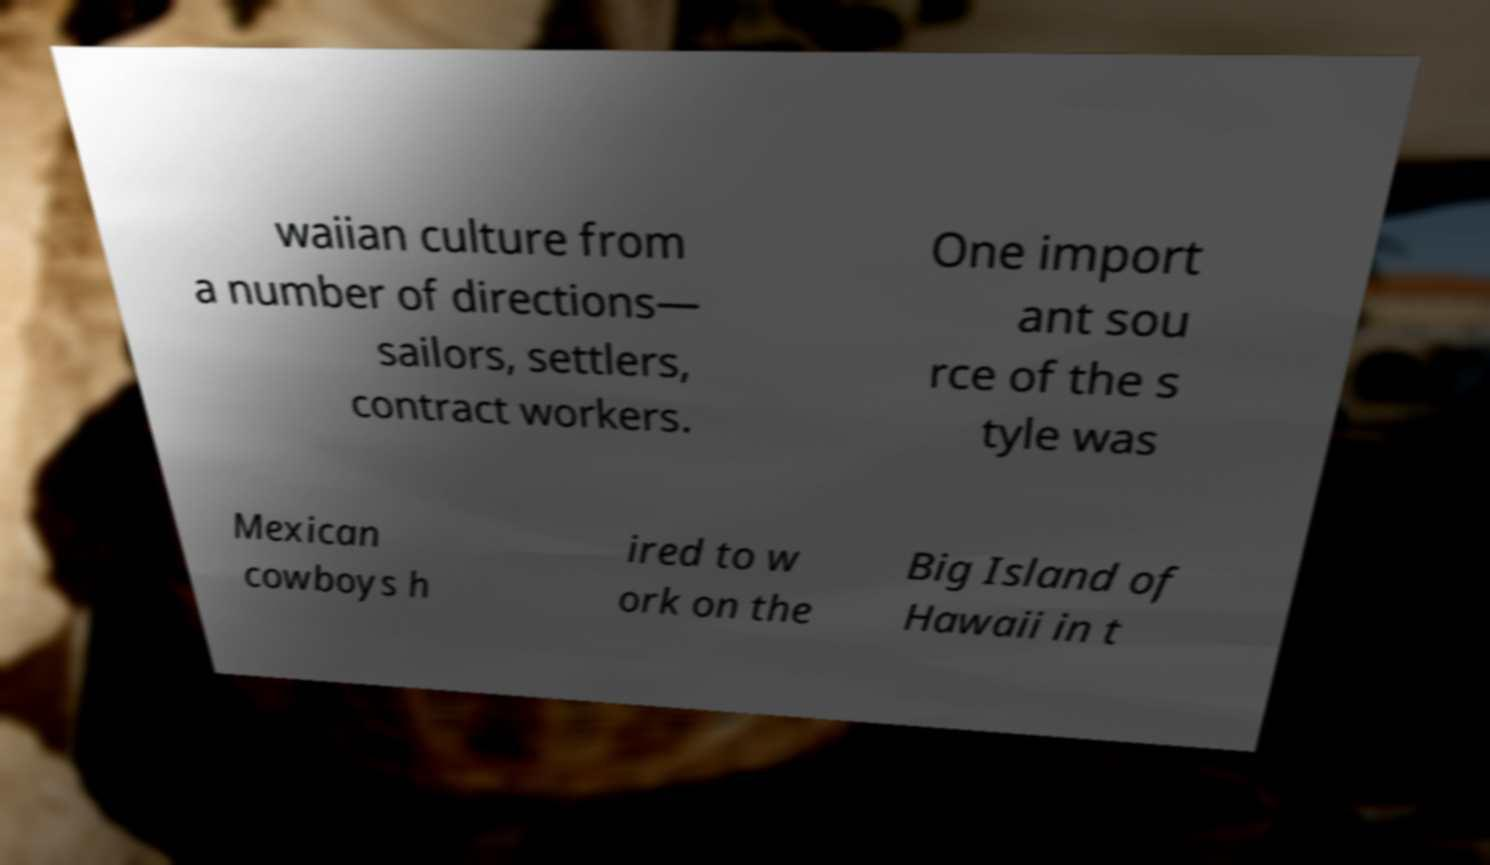Could you assist in decoding the text presented in this image and type it out clearly? waiian culture from a number of directions— sailors, settlers, contract workers. One import ant sou rce of the s tyle was Mexican cowboys h ired to w ork on the Big Island of Hawaii in t 